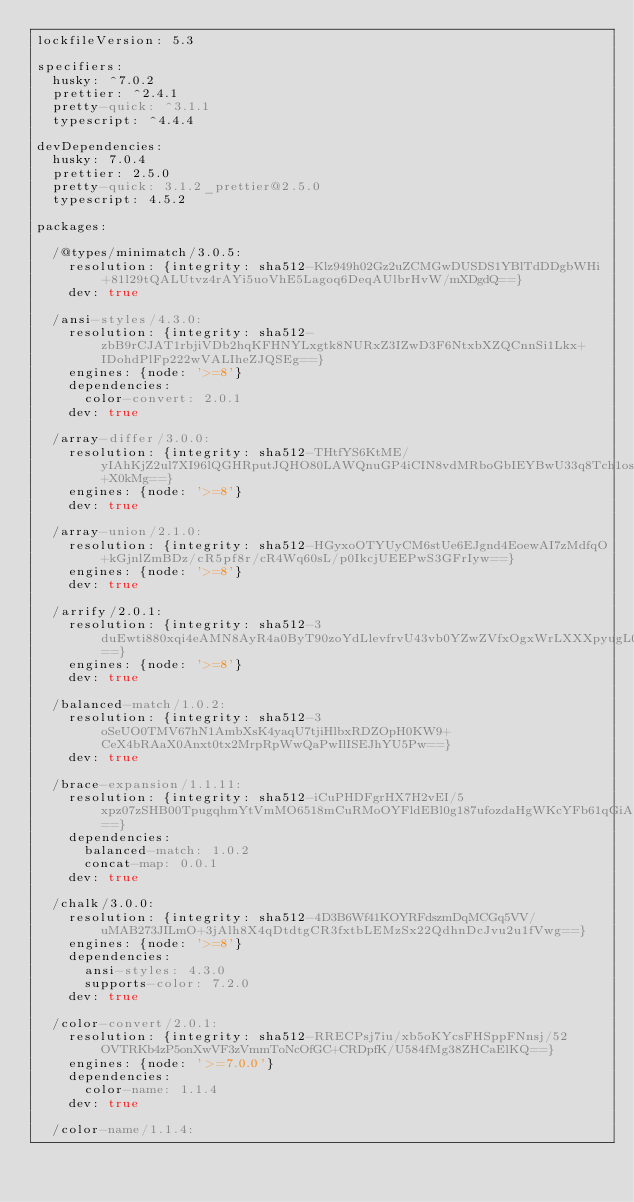<code> <loc_0><loc_0><loc_500><loc_500><_YAML_>lockfileVersion: 5.3

specifiers:
  husky: ^7.0.2
  prettier: ^2.4.1
  pretty-quick: ^3.1.1
  typescript: ^4.4.4

devDependencies:
  husky: 7.0.4
  prettier: 2.5.0
  pretty-quick: 3.1.2_prettier@2.5.0
  typescript: 4.5.2

packages:

  /@types/minimatch/3.0.5:
    resolution: {integrity: sha512-Klz949h02Gz2uZCMGwDUSDS1YBlTdDDgbWHi+81l29tQALUtvz4rAYi5uoVhE5Lagoq6DeqAUlbrHvW/mXDgdQ==}
    dev: true

  /ansi-styles/4.3.0:
    resolution: {integrity: sha512-zbB9rCJAT1rbjiVDb2hqKFHNYLxgtk8NURxZ3IZwD3F6NtxbXZQCnnSi1Lkx+IDohdPlFp222wVALIheZJQSEg==}
    engines: {node: '>=8'}
    dependencies:
      color-convert: 2.0.1
    dev: true

  /array-differ/3.0.0:
    resolution: {integrity: sha512-THtfYS6KtME/yIAhKjZ2ul7XI96lQGHRputJQHO80LAWQnuGP4iCIN8vdMRboGbIEYBwU33q8Tch1os2+X0kMg==}
    engines: {node: '>=8'}
    dev: true

  /array-union/2.1.0:
    resolution: {integrity: sha512-HGyxoOTYUyCM6stUe6EJgnd4EoewAI7zMdfqO+kGjnlZmBDz/cR5pf8r/cR4Wq60sL/p0IkcjUEEPwS3GFrIyw==}
    engines: {node: '>=8'}
    dev: true

  /arrify/2.0.1:
    resolution: {integrity: sha512-3duEwti880xqi4eAMN8AyR4a0ByT90zoYdLlevfrvU43vb0YZwZVfxOgxWrLXXXpyugL0hNZc9G6BiB5B3nUug==}
    engines: {node: '>=8'}
    dev: true

  /balanced-match/1.0.2:
    resolution: {integrity: sha512-3oSeUO0TMV67hN1AmbXsK4yaqU7tjiHlbxRDZOpH0KW9+CeX4bRAaX0Anxt0tx2MrpRpWwQaPwIlISEJhYU5Pw==}
    dev: true

  /brace-expansion/1.1.11:
    resolution: {integrity: sha512-iCuPHDFgrHX7H2vEI/5xpz07zSHB00TpugqhmYtVmMO6518mCuRMoOYFldEBl0g187ufozdaHgWKcYFb61qGiA==}
    dependencies:
      balanced-match: 1.0.2
      concat-map: 0.0.1
    dev: true

  /chalk/3.0.0:
    resolution: {integrity: sha512-4D3B6Wf41KOYRFdszmDqMCGq5VV/uMAB273JILmO+3jAlh8X4qDtdtgCR3fxtbLEMzSx22QdhnDcJvu2u1fVwg==}
    engines: {node: '>=8'}
    dependencies:
      ansi-styles: 4.3.0
      supports-color: 7.2.0
    dev: true

  /color-convert/2.0.1:
    resolution: {integrity: sha512-RRECPsj7iu/xb5oKYcsFHSppFNnsj/52OVTRKb4zP5onXwVF3zVmmToNcOfGC+CRDpfK/U584fMg38ZHCaElKQ==}
    engines: {node: '>=7.0.0'}
    dependencies:
      color-name: 1.1.4
    dev: true

  /color-name/1.1.4:</code> 